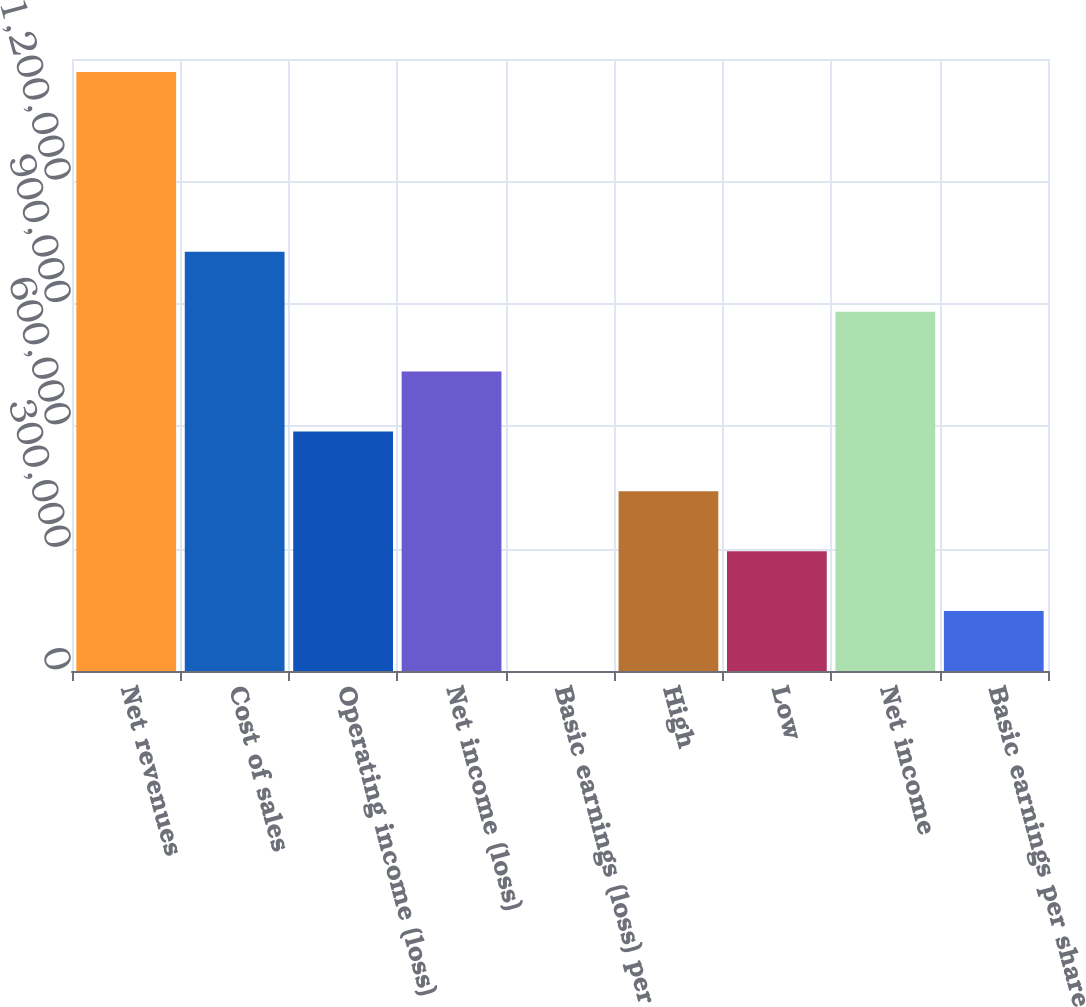<chart> <loc_0><loc_0><loc_500><loc_500><bar_chart><fcel>Net revenues<fcel>Cost of sales<fcel>Operating income (loss)<fcel>Net income (loss)<fcel>Basic earnings (loss) per<fcel>High<fcel>Low<fcel>Net income<fcel>Basic earnings per share<nl><fcel>1.468e+06<fcel>1.0276e+06<fcel>587200<fcel>734000<fcel>0.15<fcel>440400<fcel>293600<fcel>880800<fcel>146800<nl></chart> 